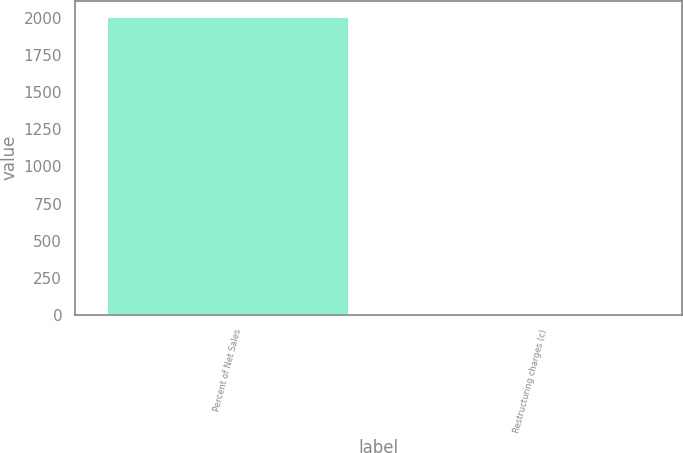<chart> <loc_0><loc_0><loc_500><loc_500><bar_chart><fcel>Percent of Net Sales<fcel>Restructuring charges (c)<nl><fcel>2018<fcel>0.5<nl></chart> 